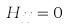Convert formula to latex. <formula><loc_0><loc_0><loc_500><loc_500>H _ { j j } = 0</formula> 